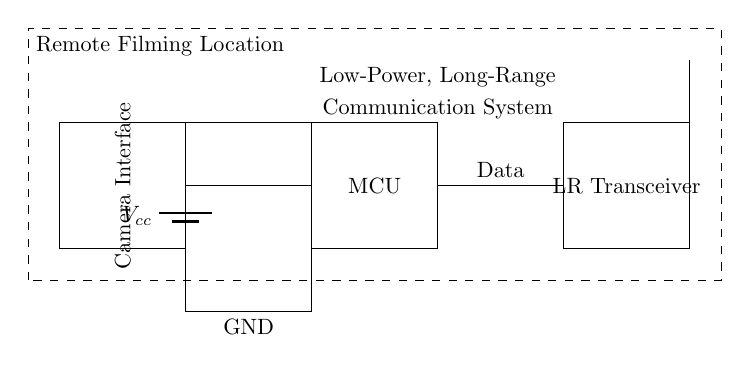What is the main power source of this circuit? The main power source is a battery, indicated in the diagram as Vcc, providing the needed voltage for the circuit.
Answer: Battery What component handles the communication in this system? The long-range transceiver is the component that manages communication, depicted in the diagram by the labeled rectangle.
Answer: LR Transceiver How many main components are visibly connected to the power source? The circuit diagram shows three components connected to the power source: the microcontroller, the camera interface, and the long-range transceiver.
Answer: Three What type of system is depicted in this circuit diagram? This circuit diagram represents a low-power, long-range communication system, as indicated in the labeled section of the diagram.
Answer: Communication System What role does the microcontroller play in this circuit? The microcontroller functions as the processing unit that probably manages the operations between components and controls data flow, based on its placement in the circuit.
Answer: Processing Unit What is the purpose of the antenna in this circuit? The antenna's purpose is to transmit or receive signals over a long distance, which is essential for communication in remote locations as depicted in the diagram.
Answer: Communication How is data transmitted from the camera interface to the transceiver? Data is transmitted from the camera interface to the transceiver through a direct connection represented by the line running from the camera interface rectangle to the transceiver.
Answer: Direct Connection 